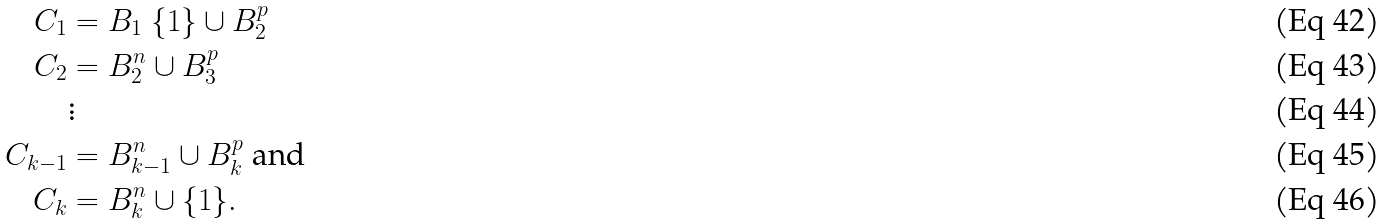<formula> <loc_0><loc_0><loc_500><loc_500>C _ { 1 } & = B _ { 1 } \ \{ 1 \} \cup B _ { 2 } ^ { p } \\ C _ { 2 } & = B _ { 2 } ^ { n } \cup B _ { 3 } ^ { p } \\ & \vdots \\ C _ { k - 1 } & = B _ { k - 1 } ^ { n } \cup B _ { k } ^ { p } \text { and} \\ C _ { k } & = B _ { k } ^ { n } \cup \{ 1 \} .</formula> 